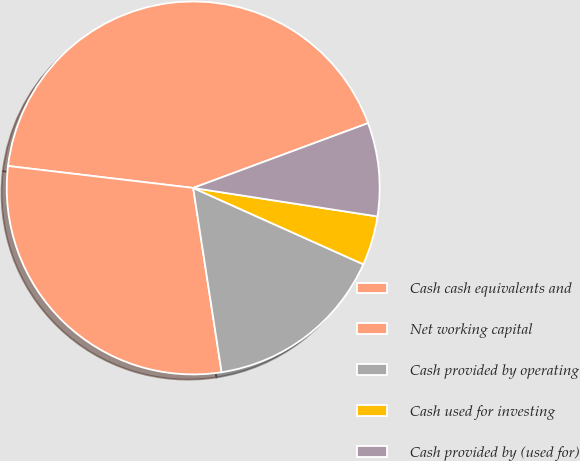Convert chart to OTSL. <chart><loc_0><loc_0><loc_500><loc_500><pie_chart><fcel>Cash cash equivalents and<fcel>Net working capital<fcel>Cash provided by operating<fcel>Cash used for investing<fcel>Cash provided by (used for)<nl><fcel>42.47%<fcel>29.31%<fcel>15.85%<fcel>4.27%<fcel>8.09%<nl></chart> 